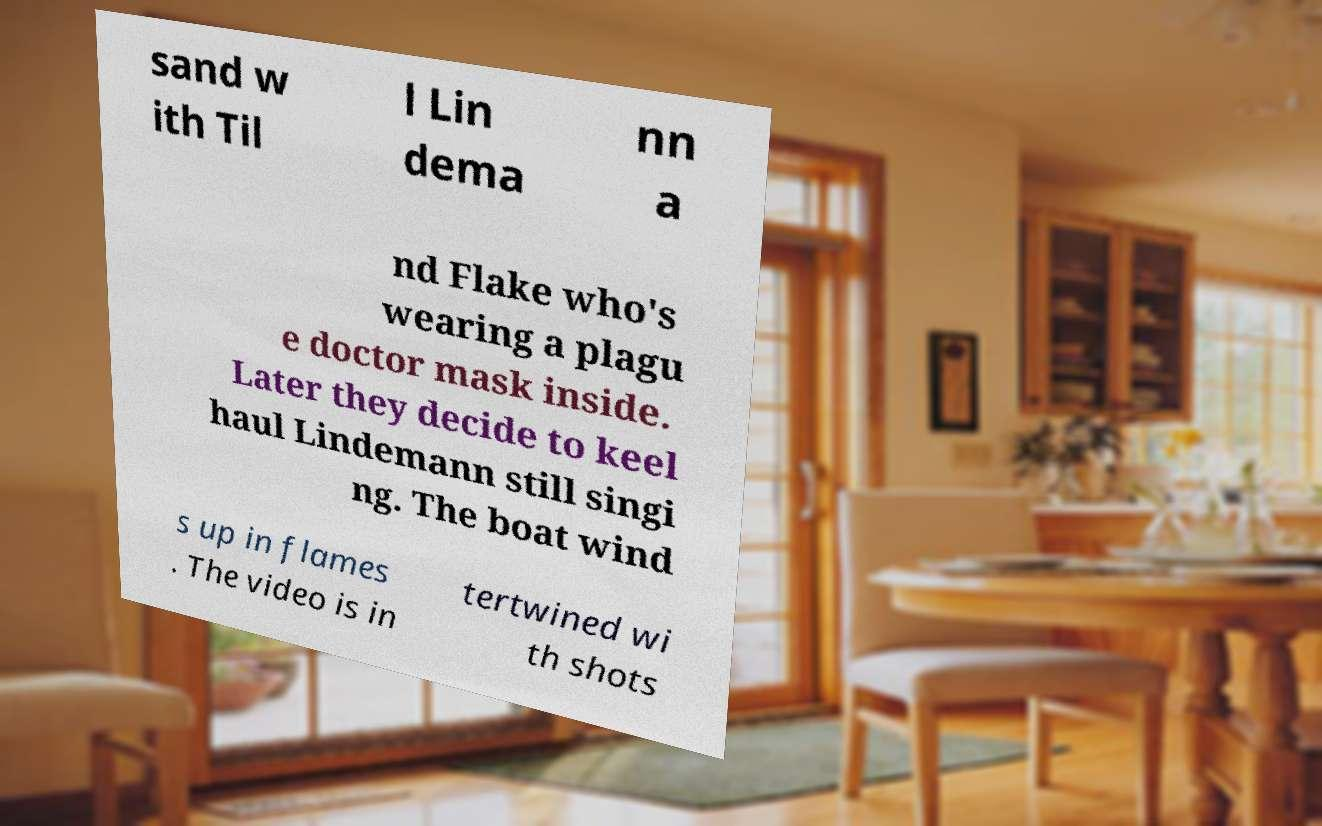There's text embedded in this image that I need extracted. Can you transcribe it verbatim? sand w ith Til l Lin dema nn a nd Flake who's wearing a plagu e doctor mask inside. Later they decide to keel haul Lindemann still singi ng. The boat wind s up in flames . The video is in tertwined wi th shots 